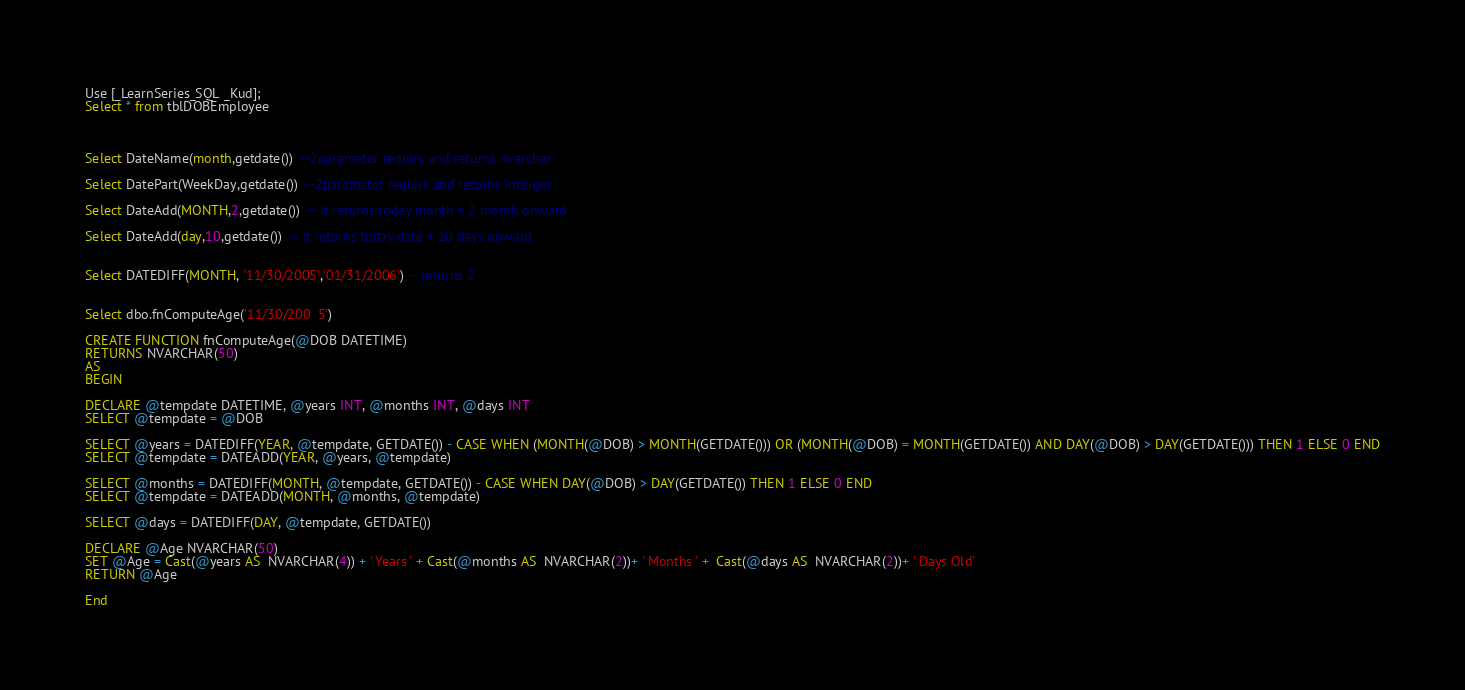Convert code to text. <code><loc_0><loc_0><loc_500><loc_500><_SQL_>
Use [_LearnSeries_SQL _Kud];
Select * from tblDOBEmployee



Select DateName(month,getdate())  --2parameter requirs and returns nvarchar 
  
Select DatePart(WeekDay,getdate())  --2parameter requirs and returns interger

Select DateAdd(MONTH,2,getdate())  -- It returns today month + 2 month onward

Select DateAdd(day,10,getdate())  -- It returns today date + 10 days onward


Select DATEDIFF(MONTH, '11/30/2005','01/31/2006') -- returns 2


Select dbo.fnComputeAge('11/30/200	5')

CREATE FUNCTION fnComputeAge(@DOB DATETIME)
RETURNS NVARCHAR(50)
AS
BEGIN

DECLARE @tempdate DATETIME, @years INT, @months INT, @days INT
SELECT @tempdate = @DOB

SELECT @years = DATEDIFF(YEAR, @tempdate, GETDATE()) - CASE WHEN (MONTH(@DOB) > MONTH(GETDATE())) OR (MONTH(@DOB) = MONTH(GETDATE()) AND DAY(@DOB) > DAY(GETDATE())) THEN 1 ELSE 0 END
SELECT @tempdate = DATEADD(YEAR, @years, @tempdate)

SELECT @months = DATEDIFF(MONTH, @tempdate, GETDATE()) - CASE WHEN DAY(@DOB) > DAY(GETDATE()) THEN 1 ELSE 0 END
SELECT @tempdate = DATEADD(MONTH, @months, @tempdate)

SELECT @days = DATEDIFF(DAY, @tempdate, GETDATE())

DECLARE @Age NVARCHAR(50)
SET @Age = Cast(@years AS  NVARCHAR(4)) + ' Years ' + Cast(@months AS  NVARCHAR(2))+ ' Months ' +  Cast(@days AS  NVARCHAR(2))+ ' Days Old'
RETURN @Age

End


</code> 